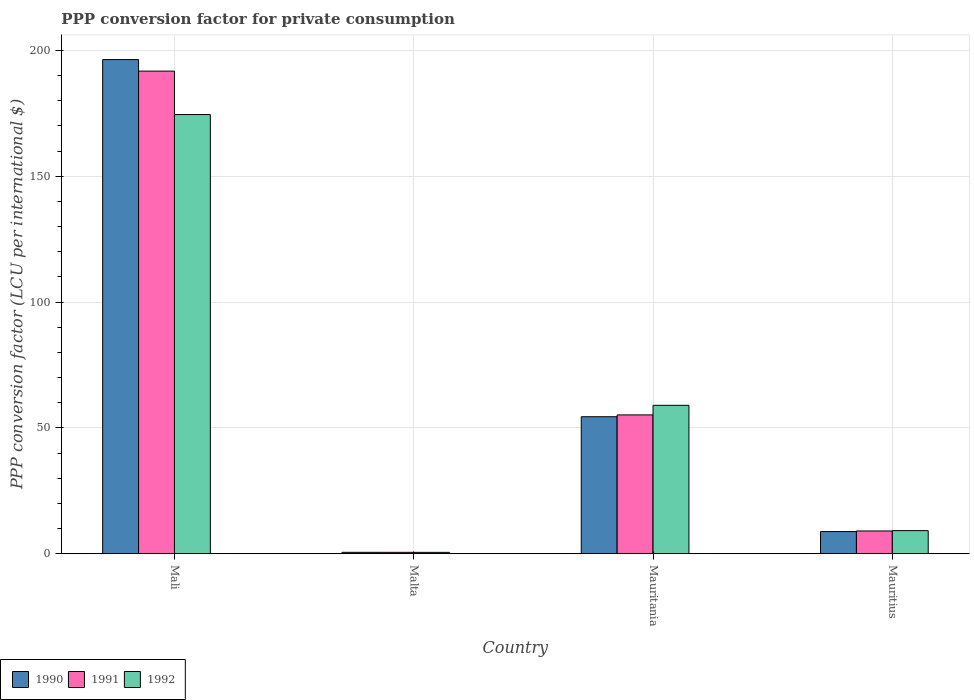How many groups of bars are there?
Offer a terse response. 4. Are the number of bars per tick equal to the number of legend labels?
Provide a short and direct response. Yes. What is the label of the 3rd group of bars from the left?
Keep it short and to the point. Mauritania. What is the PPP conversion factor for private consumption in 1990 in Malta?
Make the answer very short. 0.57. Across all countries, what is the maximum PPP conversion factor for private consumption in 1990?
Your answer should be very brief. 196.35. Across all countries, what is the minimum PPP conversion factor for private consumption in 1990?
Give a very brief answer. 0.57. In which country was the PPP conversion factor for private consumption in 1990 maximum?
Give a very brief answer. Mali. In which country was the PPP conversion factor for private consumption in 1992 minimum?
Offer a terse response. Malta. What is the total PPP conversion factor for private consumption in 1990 in the graph?
Give a very brief answer. 260.17. What is the difference between the PPP conversion factor for private consumption in 1991 in Mauritania and that in Mauritius?
Ensure brevity in your answer.  46.12. What is the difference between the PPP conversion factor for private consumption in 1992 in Malta and the PPP conversion factor for private consumption in 1990 in Mauritius?
Your answer should be very brief. -8.26. What is the average PPP conversion factor for private consumption in 1990 per country?
Keep it short and to the point. 65.04. What is the difference between the PPP conversion factor for private consumption of/in 1991 and PPP conversion factor for private consumption of/in 1990 in Mauritania?
Your answer should be very brief. 0.73. In how many countries, is the PPP conversion factor for private consumption in 1990 greater than 170 LCU?
Offer a very short reply. 1. What is the ratio of the PPP conversion factor for private consumption in 1991 in Malta to that in Mauritania?
Offer a very short reply. 0.01. Is the difference between the PPP conversion factor for private consumption in 1991 in Mauritania and Mauritius greater than the difference between the PPP conversion factor for private consumption in 1990 in Mauritania and Mauritius?
Offer a very short reply. Yes. What is the difference between the highest and the second highest PPP conversion factor for private consumption in 1990?
Keep it short and to the point. -187.54. What is the difference between the highest and the lowest PPP conversion factor for private consumption in 1992?
Provide a short and direct response. 173.95. In how many countries, is the PPP conversion factor for private consumption in 1990 greater than the average PPP conversion factor for private consumption in 1990 taken over all countries?
Your answer should be very brief. 1. Is it the case that in every country, the sum of the PPP conversion factor for private consumption in 1990 and PPP conversion factor for private consumption in 1992 is greater than the PPP conversion factor for private consumption in 1991?
Ensure brevity in your answer.  Yes. How many countries are there in the graph?
Offer a terse response. 4. What is the difference between two consecutive major ticks on the Y-axis?
Make the answer very short. 50. Where does the legend appear in the graph?
Give a very brief answer. Bottom left. How are the legend labels stacked?
Offer a very short reply. Horizontal. What is the title of the graph?
Ensure brevity in your answer.  PPP conversion factor for private consumption. What is the label or title of the Y-axis?
Make the answer very short. PPP conversion factor (LCU per international $). What is the PPP conversion factor (LCU per international $) of 1990 in Mali?
Your response must be concise. 196.35. What is the PPP conversion factor (LCU per international $) in 1991 in Mali?
Ensure brevity in your answer.  191.76. What is the PPP conversion factor (LCU per international $) of 1992 in Mali?
Provide a succinct answer. 174.51. What is the PPP conversion factor (LCU per international $) of 1990 in Malta?
Give a very brief answer. 0.57. What is the PPP conversion factor (LCU per international $) in 1991 in Malta?
Ensure brevity in your answer.  0.56. What is the PPP conversion factor (LCU per international $) in 1992 in Malta?
Give a very brief answer. 0.55. What is the PPP conversion factor (LCU per international $) of 1990 in Mauritania?
Your response must be concise. 54.44. What is the PPP conversion factor (LCU per international $) in 1991 in Mauritania?
Offer a very short reply. 55.17. What is the PPP conversion factor (LCU per international $) in 1992 in Mauritania?
Provide a short and direct response. 58.98. What is the PPP conversion factor (LCU per international $) of 1990 in Mauritius?
Your answer should be compact. 8.81. What is the PPP conversion factor (LCU per international $) of 1991 in Mauritius?
Keep it short and to the point. 9.05. What is the PPP conversion factor (LCU per international $) of 1992 in Mauritius?
Provide a succinct answer. 9.19. Across all countries, what is the maximum PPP conversion factor (LCU per international $) in 1990?
Ensure brevity in your answer.  196.35. Across all countries, what is the maximum PPP conversion factor (LCU per international $) in 1991?
Keep it short and to the point. 191.76. Across all countries, what is the maximum PPP conversion factor (LCU per international $) in 1992?
Your answer should be compact. 174.51. Across all countries, what is the minimum PPP conversion factor (LCU per international $) of 1990?
Offer a terse response. 0.57. Across all countries, what is the minimum PPP conversion factor (LCU per international $) of 1991?
Keep it short and to the point. 0.56. Across all countries, what is the minimum PPP conversion factor (LCU per international $) of 1992?
Offer a very short reply. 0.55. What is the total PPP conversion factor (LCU per international $) in 1990 in the graph?
Keep it short and to the point. 260.17. What is the total PPP conversion factor (LCU per international $) of 1991 in the graph?
Provide a succinct answer. 256.53. What is the total PPP conversion factor (LCU per international $) of 1992 in the graph?
Ensure brevity in your answer.  243.22. What is the difference between the PPP conversion factor (LCU per international $) in 1990 in Mali and that in Malta?
Ensure brevity in your answer.  195.78. What is the difference between the PPP conversion factor (LCU per international $) of 1991 in Mali and that in Malta?
Keep it short and to the point. 191.2. What is the difference between the PPP conversion factor (LCU per international $) of 1992 in Mali and that in Malta?
Your response must be concise. 173.95. What is the difference between the PPP conversion factor (LCU per international $) in 1990 in Mali and that in Mauritania?
Your answer should be very brief. 141.91. What is the difference between the PPP conversion factor (LCU per international $) of 1991 in Mali and that in Mauritania?
Your answer should be very brief. 136.59. What is the difference between the PPP conversion factor (LCU per international $) of 1992 in Mali and that in Mauritania?
Offer a terse response. 115.53. What is the difference between the PPP conversion factor (LCU per international $) in 1990 in Mali and that in Mauritius?
Make the answer very short. 187.54. What is the difference between the PPP conversion factor (LCU per international $) of 1991 in Mali and that in Mauritius?
Ensure brevity in your answer.  182.72. What is the difference between the PPP conversion factor (LCU per international $) of 1992 in Mali and that in Mauritius?
Your response must be concise. 165.32. What is the difference between the PPP conversion factor (LCU per international $) in 1990 in Malta and that in Mauritania?
Offer a very short reply. -53.87. What is the difference between the PPP conversion factor (LCU per international $) in 1991 in Malta and that in Mauritania?
Provide a succinct answer. -54.61. What is the difference between the PPP conversion factor (LCU per international $) of 1992 in Malta and that in Mauritania?
Provide a succinct answer. -58.43. What is the difference between the PPP conversion factor (LCU per international $) of 1990 in Malta and that in Mauritius?
Keep it short and to the point. -8.24. What is the difference between the PPP conversion factor (LCU per international $) in 1991 in Malta and that in Mauritius?
Your answer should be compact. -8.49. What is the difference between the PPP conversion factor (LCU per international $) of 1992 in Malta and that in Mauritius?
Your answer should be compact. -8.64. What is the difference between the PPP conversion factor (LCU per international $) in 1990 in Mauritania and that in Mauritius?
Ensure brevity in your answer.  45.63. What is the difference between the PPP conversion factor (LCU per international $) of 1991 in Mauritania and that in Mauritius?
Ensure brevity in your answer.  46.12. What is the difference between the PPP conversion factor (LCU per international $) of 1992 in Mauritania and that in Mauritius?
Provide a short and direct response. 49.79. What is the difference between the PPP conversion factor (LCU per international $) in 1990 in Mali and the PPP conversion factor (LCU per international $) in 1991 in Malta?
Provide a succinct answer. 195.79. What is the difference between the PPP conversion factor (LCU per international $) of 1990 in Mali and the PPP conversion factor (LCU per international $) of 1992 in Malta?
Make the answer very short. 195.8. What is the difference between the PPP conversion factor (LCU per international $) of 1991 in Mali and the PPP conversion factor (LCU per international $) of 1992 in Malta?
Provide a short and direct response. 191.21. What is the difference between the PPP conversion factor (LCU per international $) of 1990 in Mali and the PPP conversion factor (LCU per international $) of 1991 in Mauritania?
Provide a succinct answer. 141.18. What is the difference between the PPP conversion factor (LCU per international $) in 1990 in Mali and the PPP conversion factor (LCU per international $) in 1992 in Mauritania?
Ensure brevity in your answer.  137.37. What is the difference between the PPP conversion factor (LCU per international $) in 1991 in Mali and the PPP conversion factor (LCU per international $) in 1992 in Mauritania?
Give a very brief answer. 132.78. What is the difference between the PPP conversion factor (LCU per international $) in 1990 in Mali and the PPP conversion factor (LCU per international $) in 1991 in Mauritius?
Your answer should be very brief. 187.3. What is the difference between the PPP conversion factor (LCU per international $) of 1990 in Mali and the PPP conversion factor (LCU per international $) of 1992 in Mauritius?
Offer a very short reply. 187.16. What is the difference between the PPP conversion factor (LCU per international $) of 1991 in Mali and the PPP conversion factor (LCU per international $) of 1992 in Mauritius?
Provide a succinct answer. 182.57. What is the difference between the PPP conversion factor (LCU per international $) of 1990 in Malta and the PPP conversion factor (LCU per international $) of 1991 in Mauritania?
Offer a terse response. -54.6. What is the difference between the PPP conversion factor (LCU per international $) of 1990 in Malta and the PPP conversion factor (LCU per international $) of 1992 in Mauritania?
Your response must be concise. -58.41. What is the difference between the PPP conversion factor (LCU per international $) of 1991 in Malta and the PPP conversion factor (LCU per international $) of 1992 in Mauritania?
Give a very brief answer. -58.42. What is the difference between the PPP conversion factor (LCU per international $) of 1990 in Malta and the PPP conversion factor (LCU per international $) of 1991 in Mauritius?
Ensure brevity in your answer.  -8.48. What is the difference between the PPP conversion factor (LCU per international $) in 1990 in Malta and the PPP conversion factor (LCU per international $) in 1992 in Mauritius?
Your response must be concise. -8.62. What is the difference between the PPP conversion factor (LCU per international $) of 1991 in Malta and the PPP conversion factor (LCU per international $) of 1992 in Mauritius?
Offer a terse response. -8.63. What is the difference between the PPP conversion factor (LCU per international $) of 1990 in Mauritania and the PPP conversion factor (LCU per international $) of 1991 in Mauritius?
Offer a terse response. 45.39. What is the difference between the PPP conversion factor (LCU per international $) in 1990 in Mauritania and the PPP conversion factor (LCU per international $) in 1992 in Mauritius?
Ensure brevity in your answer.  45.25. What is the difference between the PPP conversion factor (LCU per international $) of 1991 in Mauritania and the PPP conversion factor (LCU per international $) of 1992 in Mauritius?
Your response must be concise. 45.98. What is the average PPP conversion factor (LCU per international $) in 1990 per country?
Offer a terse response. 65.04. What is the average PPP conversion factor (LCU per international $) of 1991 per country?
Provide a short and direct response. 64.13. What is the average PPP conversion factor (LCU per international $) of 1992 per country?
Your answer should be very brief. 60.8. What is the difference between the PPP conversion factor (LCU per international $) in 1990 and PPP conversion factor (LCU per international $) in 1991 in Mali?
Your answer should be very brief. 4.59. What is the difference between the PPP conversion factor (LCU per international $) of 1990 and PPP conversion factor (LCU per international $) of 1992 in Mali?
Provide a succinct answer. 21.84. What is the difference between the PPP conversion factor (LCU per international $) of 1991 and PPP conversion factor (LCU per international $) of 1992 in Mali?
Your response must be concise. 17.26. What is the difference between the PPP conversion factor (LCU per international $) in 1990 and PPP conversion factor (LCU per international $) in 1991 in Malta?
Make the answer very short. 0.01. What is the difference between the PPP conversion factor (LCU per international $) of 1990 and PPP conversion factor (LCU per international $) of 1992 in Malta?
Ensure brevity in your answer.  0.02. What is the difference between the PPP conversion factor (LCU per international $) of 1991 and PPP conversion factor (LCU per international $) of 1992 in Malta?
Your answer should be very brief. 0.01. What is the difference between the PPP conversion factor (LCU per international $) in 1990 and PPP conversion factor (LCU per international $) in 1991 in Mauritania?
Make the answer very short. -0.73. What is the difference between the PPP conversion factor (LCU per international $) in 1990 and PPP conversion factor (LCU per international $) in 1992 in Mauritania?
Make the answer very short. -4.54. What is the difference between the PPP conversion factor (LCU per international $) in 1991 and PPP conversion factor (LCU per international $) in 1992 in Mauritania?
Give a very brief answer. -3.81. What is the difference between the PPP conversion factor (LCU per international $) of 1990 and PPP conversion factor (LCU per international $) of 1991 in Mauritius?
Make the answer very short. -0.23. What is the difference between the PPP conversion factor (LCU per international $) in 1990 and PPP conversion factor (LCU per international $) in 1992 in Mauritius?
Give a very brief answer. -0.38. What is the difference between the PPP conversion factor (LCU per international $) in 1991 and PPP conversion factor (LCU per international $) in 1992 in Mauritius?
Your answer should be very brief. -0.14. What is the ratio of the PPP conversion factor (LCU per international $) in 1990 in Mali to that in Malta?
Keep it short and to the point. 346.22. What is the ratio of the PPP conversion factor (LCU per international $) in 1991 in Mali to that in Malta?
Make the answer very short. 343.72. What is the ratio of the PPP conversion factor (LCU per international $) in 1992 in Mali to that in Malta?
Ensure brevity in your answer.  317.08. What is the ratio of the PPP conversion factor (LCU per international $) in 1990 in Mali to that in Mauritania?
Your answer should be very brief. 3.61. What is the ratio of the PPP conversion factor (LCU per international $) in 1991 in Mali to that in Mauritania?
Your answer should be compact. 3.48. What is the ratio of the PPP conversion factor (LCU per international $) in 1992 in Mali to that in Mauritania?
Ensure brevity in your answer.  2.96. What is the ratio of the PPP conversion factor (LCU per international $) in 1990 in Mali to that in Mauritius?
Offer a terse response. 22.28. What is the ratio of the PPP conversion factor (LCU per international $) of 1991 in Mali to that in Mauritius?
Ensure brevity in your answer.  21.2. What is the ratio of the PPP conversion factor (LCU per international $) in 1992 in Mali to that in Mauritius?
Offer a very short reply. 18.99. What is the ratio of the PPP conversion factor (LCU per international $) of 1990 in Malta to that in Mauritania?
Provide a succinct answer. 0.01. What is the ratio of the PPP conversion factor (LCU per international $) in 1991 in Malta to that in Mauritania?
Ensure brevity in your answer.  0.01. What is the ratio of the PPP conversion factor (LCU per international $) in 1992 in Malta to that in Mauritania?
Offer a terse response. 0.01. What is the ratio of the PPP conversion factor (LCU per international $) in 1990 in Malta to that in Mauritius?
Make the answer very short. 0.06. What is the ratio of the PPP conversion factor (LCU per international $) of 1991 in Malta to that in Mauritius?
Your response must be concise. 0.06. What is the ratio of the PPP conversion factor (LCU per international $) of 1992 in Malta to that in Mauritius?
Offer a very short reply. 0.06. What is the ratio of the PPP conversion factor (LCU per international $) of 1990 in Mauritania to that in Mauritius?
Offer a terse response. 6.18. What is the ratio of the PPP conversion factor (LCU per international $) in 1991 in Mauritania to that in Mauritius?
Offer a very short reply. 6.1. What is the ratio of the PPP conversion factor (LCU per international $) of 1992 in Mauritania to that in Mauritius?
Your response must be concise. 6.42. What is the difference between the highest and the second highest PPP conversion factor (LCU per international $) in 1990?
Keep it short and to the point. 141.91. What is the difference between the highest and the second highest PPP conversion factor (LCU per international $) in 1991?
Your answer should be compact. 136.59. What is the difference between the highest and the second highest PPP conversion factor (LCU per international $) of 1992?
Keep it short and to the point. 115.53. What is the difference between the highest and the lowest PPP conversion factor (LCU per international $) of 1990?
Offer a very short reply. 195.78. What is the difference between the highest and the lowest PPP conversion factor (LCU per international $) in 1991?
Ensure brevity in your answer.  191.2. What is the difference between the highest and the lowest PPP conversion factor (LCU per international $) of 1992?
Offer a terse response. 173.95. 